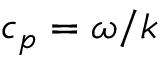<formula> <loc_0><loc_0><loc_500><loc_500>c _ { p } = \omega / k</formula> 